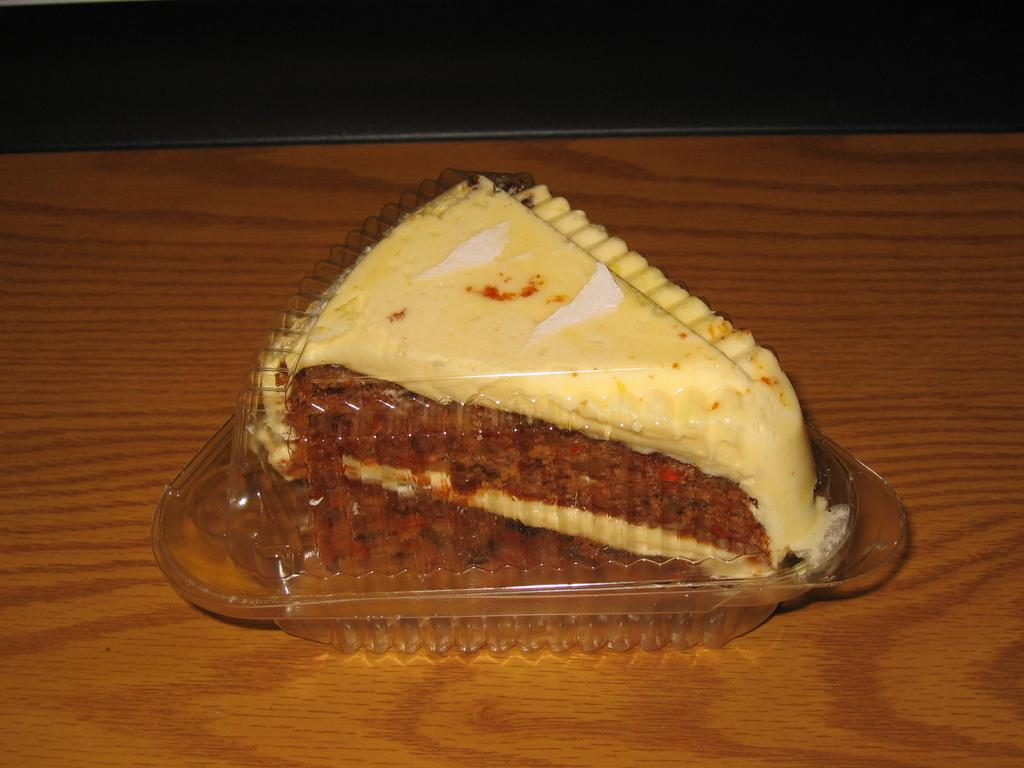What is the main subject of the image? There is a piece of cake in the image. How is the cake being stored or contained? The cake is packed in a plastic box. On what surface is the plastic box placed? The plastic box is placed on a wooden table. What type of money is visible in the image? There is no money visible in the image. How does the cake taste in the image? The taste of the cake cannot be determined from the image alone, as taste is a sensory experience. 